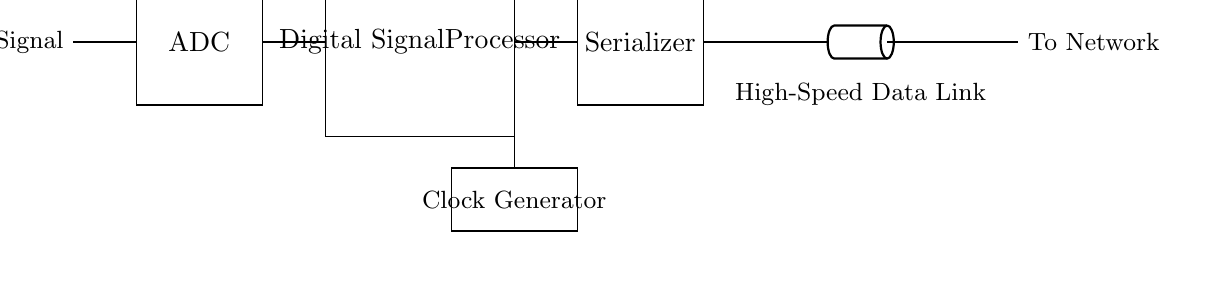What are the main components in this circuit? The circuit includes the following components: Input Signal, ADC, Digital Signal Processor, Serializer, Clock Generator, and Transmission Line. These components are connected sequentially, starting from the input signal to the output transmission line.
Answer: Input Signal, ADC, Digital Signal Processor, Serializer, Clock Generator, Transmission Line What is the purpose of the ADC in this circuit? The purpose of the ADC (Analog-to-Digital Converter) is to convert the incoming analog signal into a digital signal that can be processed by the Digital Signal Processor following it. This step is crucial for digital data processing in video streaming applications.
Answer: Conversion of analog to digital Which component generates the timing for data transmission? The Clock Generator provides the necessary clock signal that synchronizes the operation of the Digital Signal Processor and Serializer, ensuring data is transmitted at the correct timing and speed.
Answer: Clock Generator How many distinct stages are present in this circuit diagram? The circuit diagram outlines five distinct stages: Input Signal, ADC, Digital Signal Processor, Serializer, and Transmission Line. Each serves a unique function in the overall data transmission process.
Answer: Five What type of data is this circuit designed to transmit? The circuit is specifically designed for high-speed data transmission, particularly for video streaming applications, indicating a requirement for efficient data handling.
Answer: High-speed video data What connects the Digital Signal Processor to the Serializer? A short direct connection line is used to connect the output of the Digital Signal Processor to the input of the Serializer, enabling the transfer of processed digital data to be serialized for transmission.
Answer: Direct connection line What does the presence of the Transmission Line indicate about the circuit's application? The inclusion of a Transmission Line signifies that this circuit is intended for long-distance data transmission, often required in networking contexts where video streaming data must be sent efficiently.
Answer: Long-distance transmission 